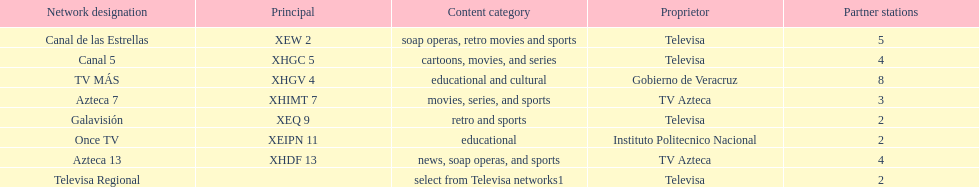Which owner has the most networks? Televisa. 